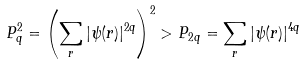Convert formula to latex. <formula><loc_0><loc_0><loc_500><loc_500>P _ { q } ^ { 2 } = \left ( \sum _ { r } | \psi ( r ) | ^ { 2 q } \right ) ^ { 2 } > P _ { 2 q } = \sum _ { r } | \psi ( r ) | ^ { 4 q }</formula> 